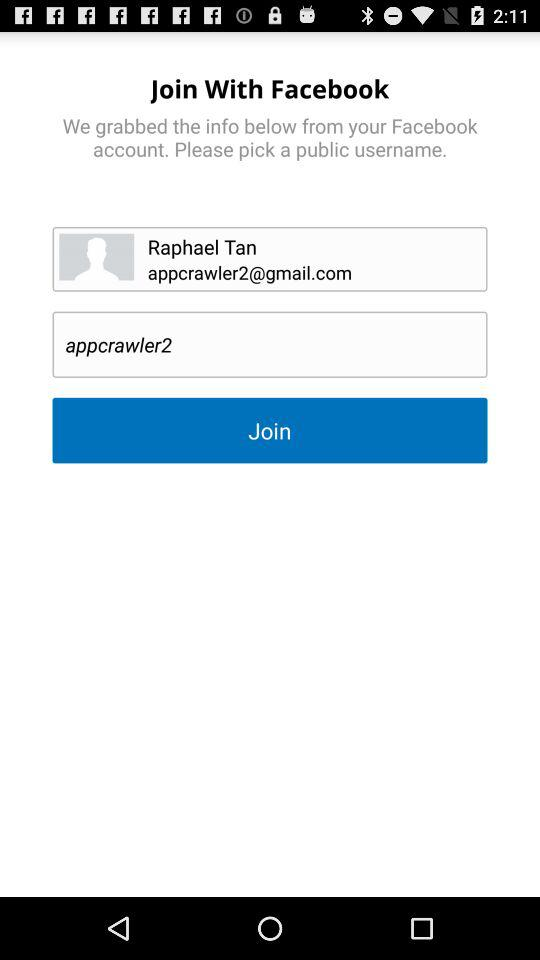What is the name of the user? The name of the user is Raphael Tan. 